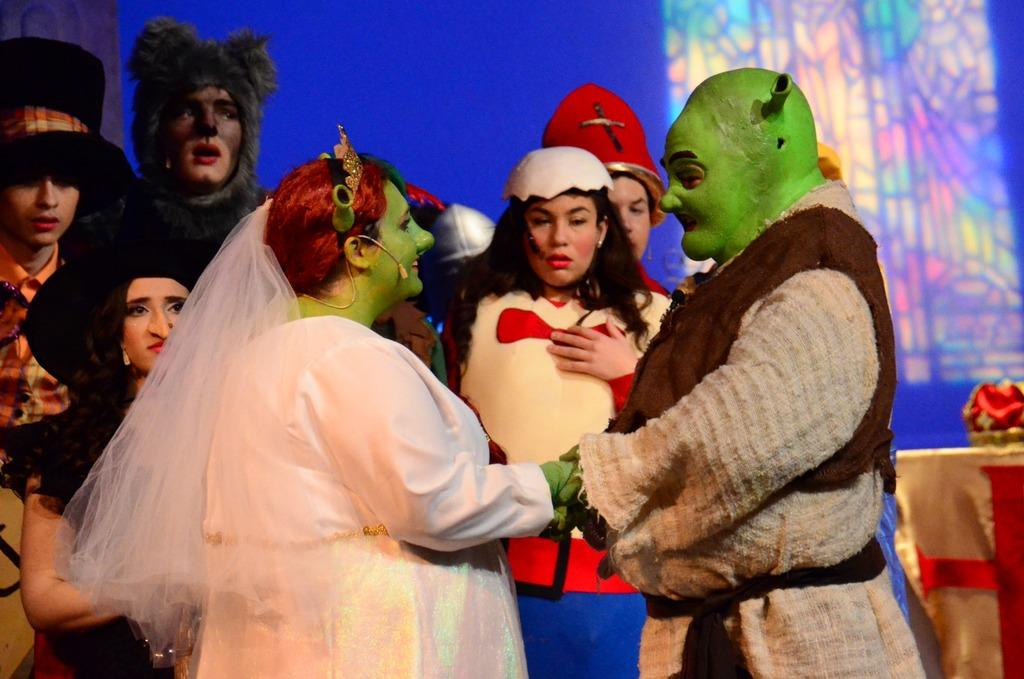What are the people in the image wearing? The people in the image are wearing different costumes. Can you describe the colors of the costumes? The costumes are in different colors. What can be seen behind the people in the image? There is a colorful background in the image. What else is present in the image besides the people and the background? There are objects present around the people. What type of wax can be seen melting on the sheep in the image? There is no sheep or wax present in the image; it features people wearing costumes with a colorful background and objects around them. 